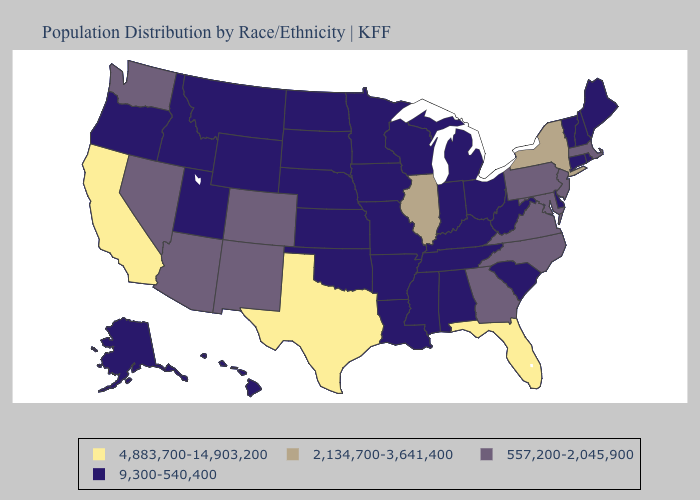What is the value of Iowa?
Answer briefly. 9,300-540,400. What is the lowest value in states that border Virginia?
Concise answer only. 9,300-540,400. Name the states that have a value in the range 557,200-2,045,900?
Quick response, please. Arizona, Colorado, Georgia, Maryland, Massachusetts, Nevada, New Jersey, New Mexico, North Carolina, Pennsylvania, Virginia, Washington. What is the lowest value in states that border Georgia?
Write a very short answer. 9,300-540,400. What is the value of Michigan?
Short answer required. 9,300-540,400. Does West Virginia have the lowest value in the USA?
Quick response, please. Yes. Among the states that border Tennessee , which have the highest value?
Short answer required. Georgia, North Carolina, Virginia. Name the states that have a value in the range 2,134,700-3,641,400?
Concise answer only. Illinois, New York. Among the states that border Arizona , which have the lowest value?
Short answer required. Utah. What is the lowest value in the USA?
Concise answer only. 9,300-540,400. Which states have the highest value in the USA?
Concise answer only. California, Florida, Texas. Which states have the lowest value in the USA?
Concise answer only. Alabama, Alaska, Arkansas, Connecticut, Delaware, Hawaii, Idaho, Indiana, Iowa, Kansas, Kentucky, Louisiana, Maine, Michigan, Minnesota, Mississippi, Missouri, Montana, Nebraska, New Hampshire, North Dakota, Ohio, Oklahoma, Oregon, Rhode Island, South Carolina, South Dakota, Tennessee, Utah, Vermont, West Virginia, Wisconsin, Wyoming. Which states hav the highest value in the MidWest?
Answer briefly. Illinois. Does Texas have the highest value in the USA?
Answer briefly. Yes. 